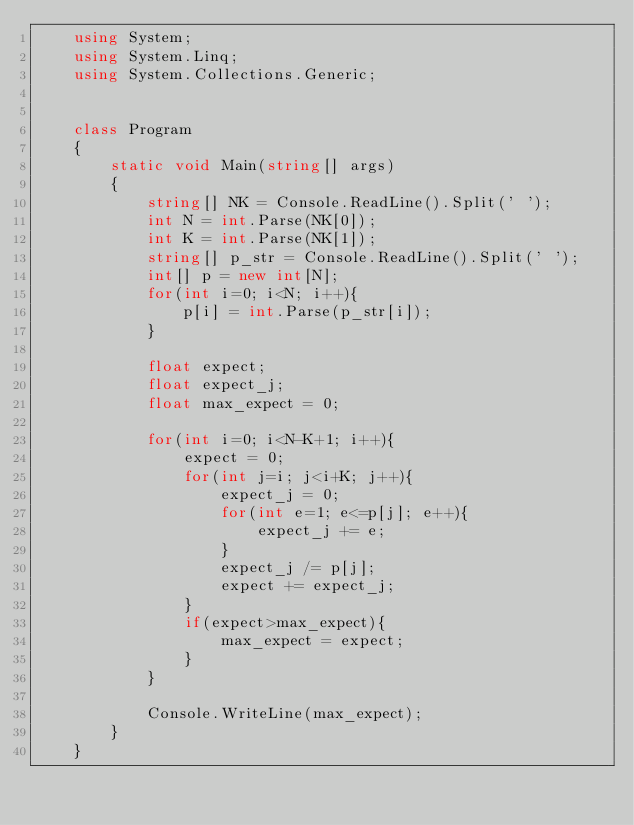<code> <loc_0><loc_0><loc_500><loc_500><_C#_>    using System;
    using System.Linq;
    using System.Collections.Generic;


    class Program
    {
        static void Main(string[] args)
        {
            string[] NK = Console.ReadLine().Split(' ');
            int N = int.Parse(NK[0]);
            int K = int.Parse(NK[1]);
            string[] p_str = Console.ReadLine().Split(' ');
            int[] p = new int[N];
            for(int i=0; i<N; i++){
                p[i] = int.Parse(p_str[i]);
            }

            float expect;
            float expect_j;
            float max_expect = 0;

            for(int i=0; i<N-K+1; i++){
                expect = 0;
                for(int j=i; j<i+K; j++){
                    expect_j = 0;
                    for(int e=1; e<=p[j]; e++){
                        expect_j += e;
                    }
                    expect_j /= p[j];
                    expect += expect_j;
                }
                if(expect>max_expect){
                    max_expect = expect;
                }
            }

            Console.WriteLine(max_expect);
        }
    }</code> 